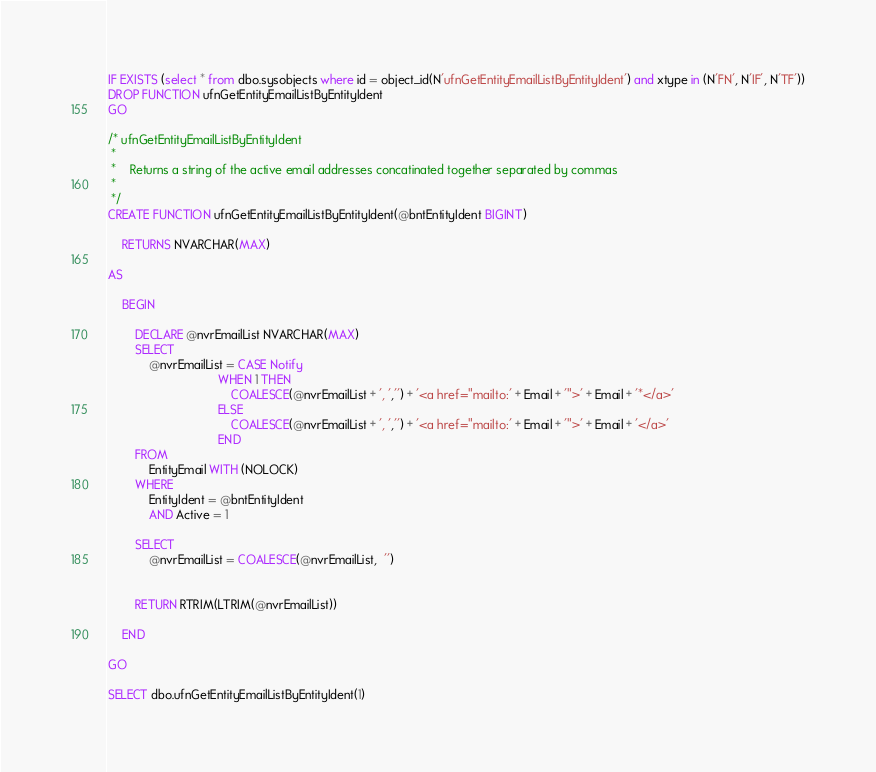Convert code to text. <code><loc_0><loc_0><loc_500><loc_500><_SQL_>IF EXISTS (select * from dbo.sysobjects where id = object_id(N'ufnGetEntityEmailListByEntityIdent') and xtype in (N'FN', N'IF', N'TF'))
DROP FUNCTION ufnGetEntityEmailListByEntityIdent
GO

/* ufnGetEntityEmailListByEntityIdent
 *
 *	Returns a string of the active email addresses concatinated together separated by commas
 *
 */
CREATE FUNCTION ufnGetEntityEmailListByEntityIdent(@bntEntityIdent BIGINT)

	RETURNS NVARCHAR(MAX)

AS

	BEGIN
		
		DECLARE @nvrEmailList NVARCHAR(MAX)
		SELECT 
			@nvrEmailList = CASE Notify 
								WHEN 1 THEN 
									COALESCE(@nvrEmailList + ', ','') + '<a href="mailto:' + Email + '">' + Email + '*</a>'
								ELSE
									COALESCE(@nvrEmailList + ', ','') + '<a href="mailto:' + Email + '">' + Email + '</a>'
								END 
		FROM 
			EntityEmail WITH (NOLOCK)
		WHERE 
			EntityIdent = @bntEntityIdent
			AND Active = 1

		SELECT 
			@nvrEmailList = COALESCE(@nvrEmailList,  '')


		RETURN RTRIM(LTRIM(@nvrEmailList))

	END
	
GO

SELECT dbo.ufnGetEntityEmailListByEntityIdent(1)</code> 